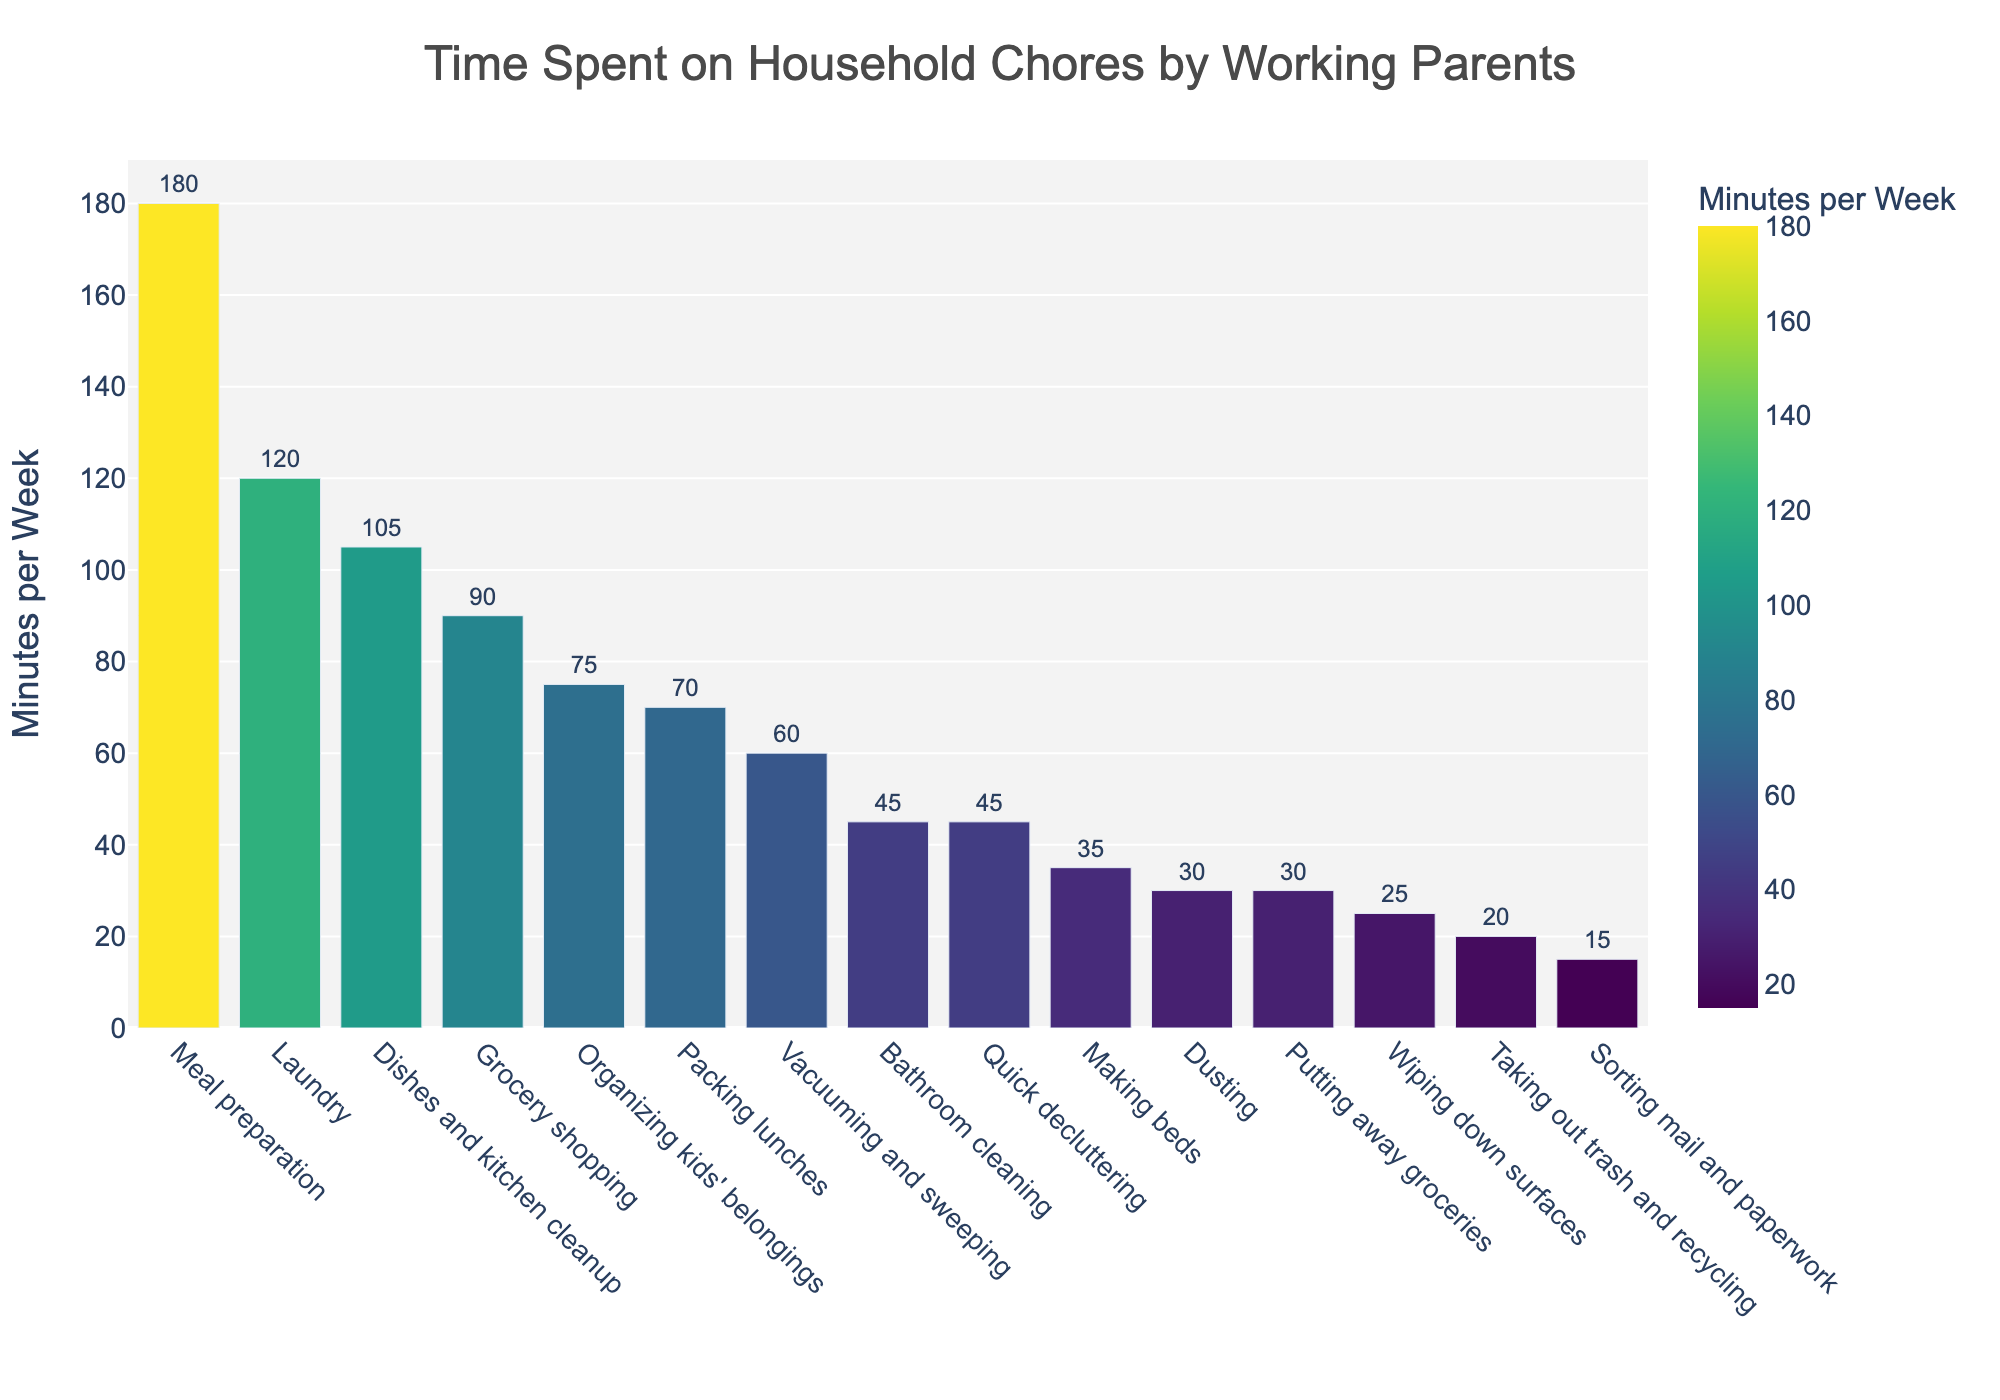Which task takes the most time per week? The bar chart shows that "Meal preparation" has the highest bar, indicating it takes the most time per week.
Answer: Meal preparation How much more time is spent on laundry compared to vacuuming and sweeping? The time spent on laundry is 120 minutes and on vacuuming and sweeping is 60 minutes. Subtract the smaller value from the larger value: 120 - 60 = 60 minutes.
Answer: 60 minutes Which tasks take less than 50 minutes per week? Tasks with bars shorter than 50 minutes are: Dusting (30), Taking out trash and recycling (20), Wiping down surfaces (25), Sorting mail and paperwork (15), Putting away groceries (30).
Answer: Dusting, Taking out trash and recycling, Wiping down surfaces, Sorting mail and paperwork, Putting away groceries What is the total time spent on all household chores per week? Add up the minutes for all the tasks: 120 + 180 + 105 + 60 + 45 + 90 + 75 + 30 + 20 + 45 + 35 + 25 + 15 + 70 + 30 = 945 minutes.
Answer: 945 minutes Which takes more time: grocery shopping or packing lunches? Compare the heights of the bars for Grocery shopping (90 minutes) and Packing lunches (70 minutes). Grocery shopping takes more time.
Answer: Grocery shopping What is the average time spent on the top 5 most time-consuming tasks? The top 5 tasks are: Meal preparation (180), Laundry (120), Dishes and kitchen cleanup (105), Grocery shopping (90), and Organizing kids' belongings (75). Calculate the average: (180 + 120 + 105 + 90 + 75) / 5 = 114 minutes.
Answer: 114 minutes How much more time is spent on quick decluttering than on taking out trash and recycling? The time spent on quick decluttering is 45 minutes and taking out trash and recycling is 20 minutes. Subtract the smaller value from the larger value: 45 - 20 = 25 minutes.
Answer: 25 minutes What fraction of the total time is spent on bathroom cleaning? The time spent on bathroom cleaning is 45 minutes. The total time for all tasks is 945 minutes. The fraction is 45 / 945, which simplifies to 1/21.
Answer: 1/21 Which task takes almost as much time as vacuuming and sweeping? The bar for Making beds (35 minutes) is closest in height to the bar for Vacuuming and sweeping (60 minutes).
Answer: Making beds 